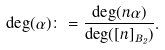Convert formula to latex. <formula><loc_0><loc_0><loc_500><loc_500>\deg ( \alpha ) \colon = \frac { \deg ( n \alpha ) } { \deg ( [ n ] _ { B _ { 2 } } ) } .</formula> 